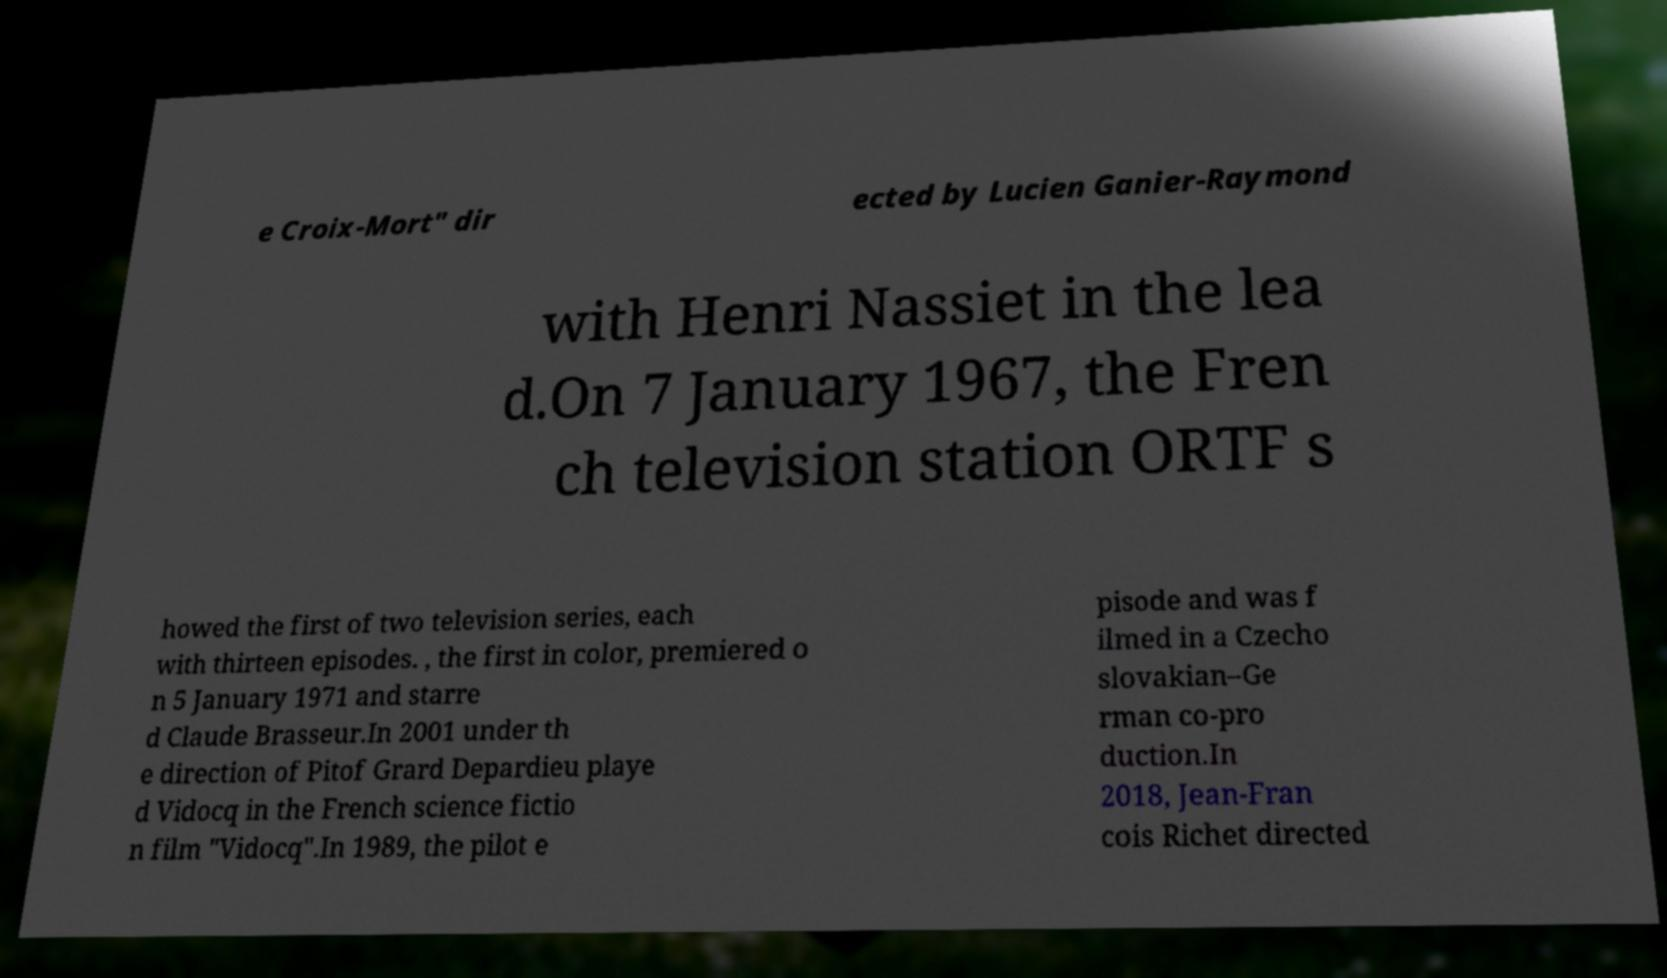What messages or text are displayed in this image? I need them in a readable, typed format. e Croix-Mort" dir ected by Lucien Ganier-Raymond with Henri Nassiet in the lea d.On 7 January 1967, the Fren ch television station ORTF s howed the first of two television series, each with thirteen episodes. , the first in color, premiered o n 5 January 1971 and starre d Claude Brasseur.In 2001 under th e direction of Pitof Grard Depardieu playe d Vidocq in the French science fictio n film "Vidocq".In 1989, the pilot e pisode and was f ilmed in a Czecho slovakian–Ge rman co-pro duction.In 2018, Jean-Fran cois Richet directed 